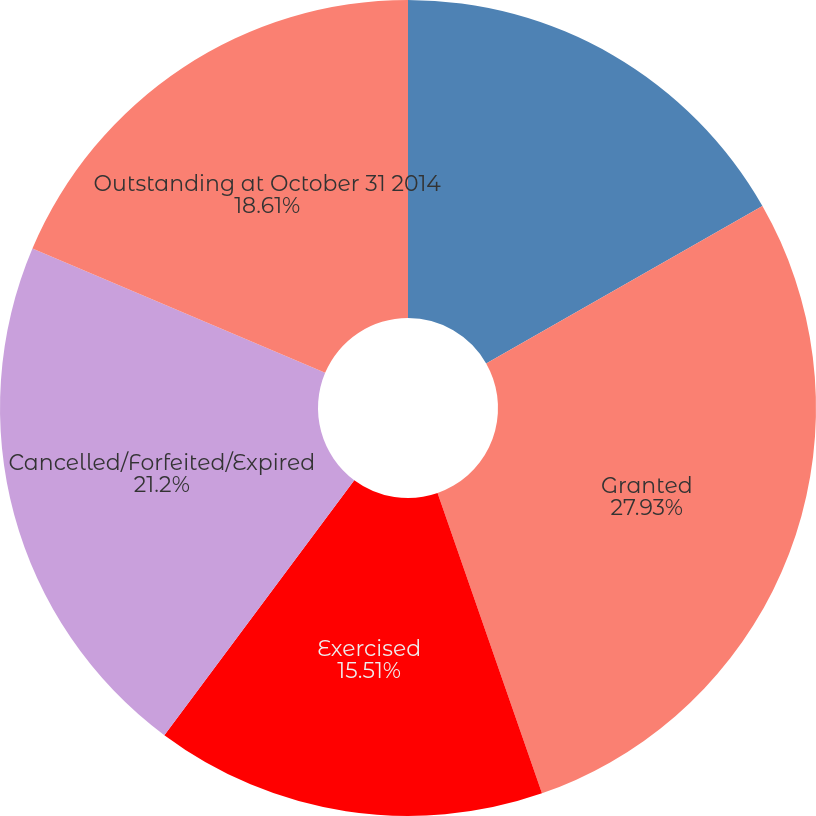Convert chart to OTSL. <chart><loc_0><loc_0><loc_500><loc_500><pie_chart><fcel>Outstanding at October 31 2013<fcel>Granted<fcel>Exercised<fcel>Cancelled/Forfeited/Expired<fcel>Outstanding at October 31 2014<nl><fcel>16.75%<fcel>27.92%<fcel>15.51%<fcel>21.2%<fcel>18.61%<nl></chart> 